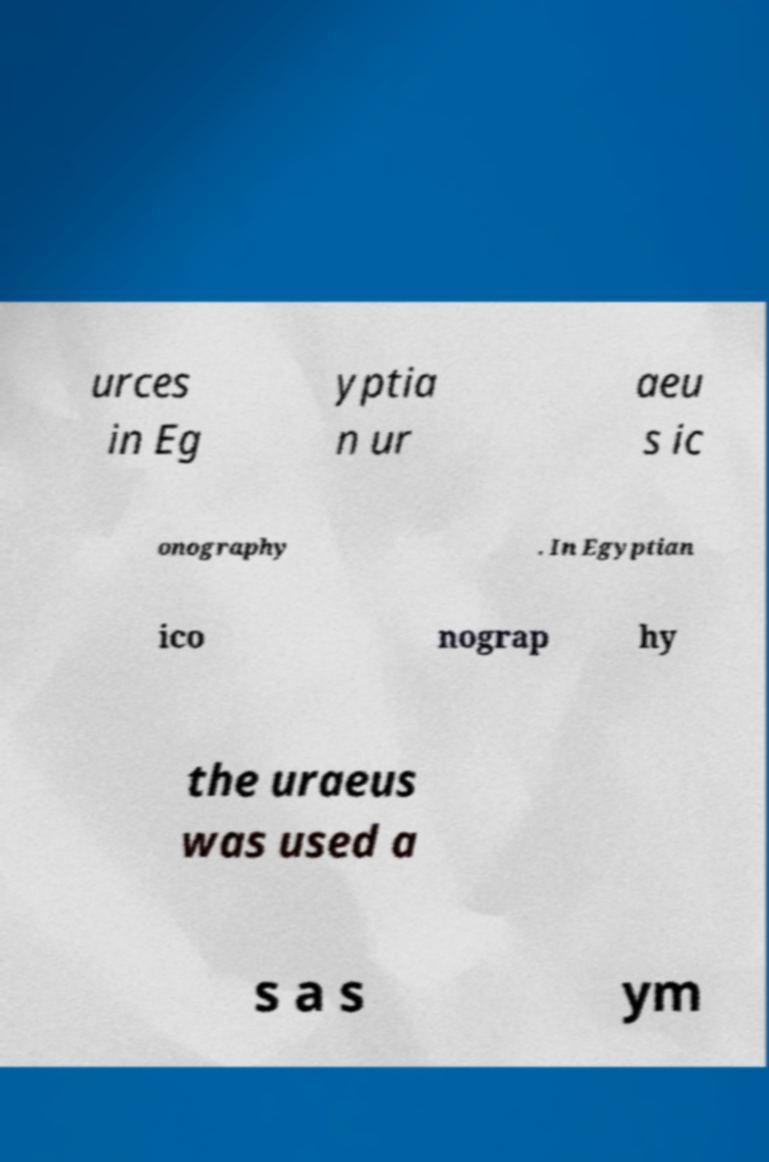For documentation purposes, I need the text within this image transcribed. Could you provide that? urces in Eg yptia n ur aeu s ic onography . In Egyptian ico nograp hy the uraeus was used a s a s ym 